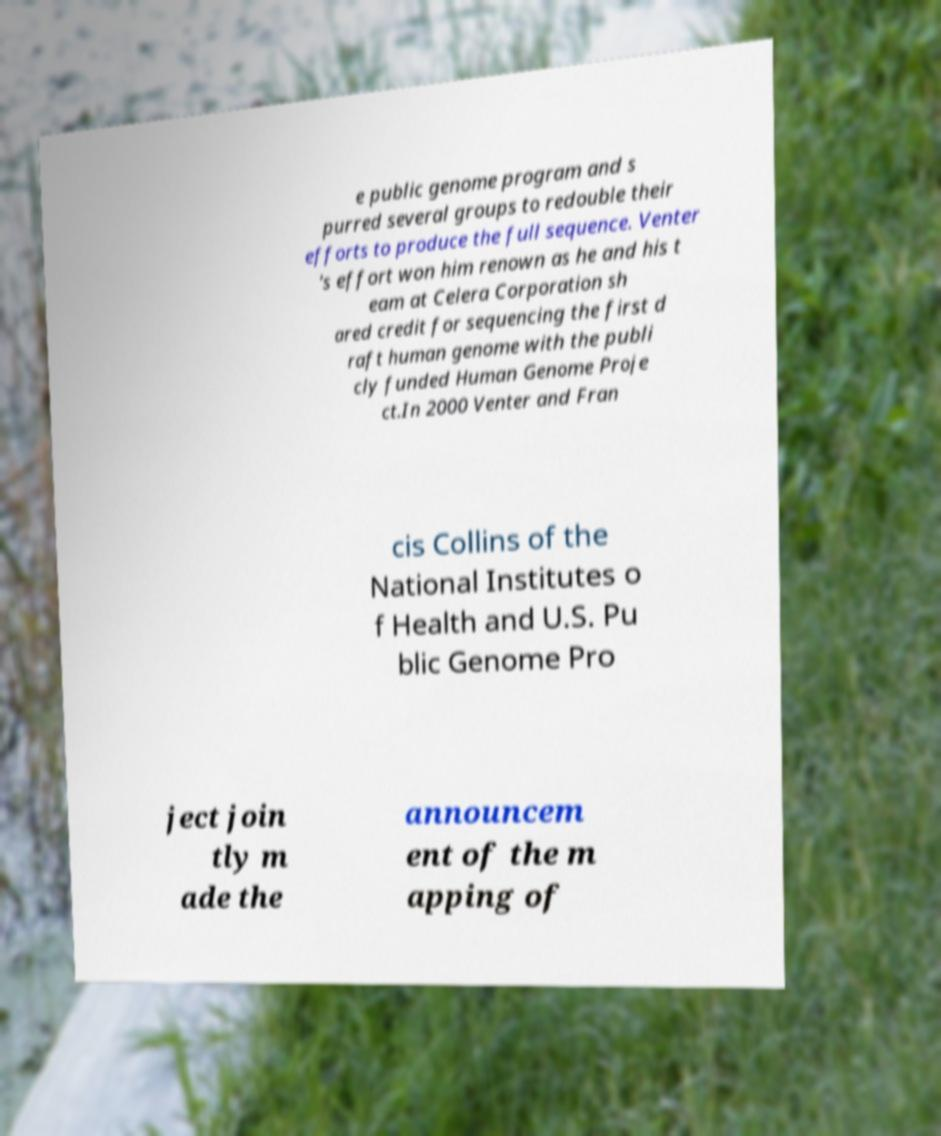Please read and relay the text visible in this image. What does it say? e public genome program and s purred several groups to redouble their efforts to produce the full sequence. Venter 's effort won him renown as he and his t eam at Celera Corporation sh ared credit for sequencing the first d raft human genome with the publi cly funded Human Genome Proje ct.In 2000 Venter and Fran cis Collins of the National Institutes o f Health and U.S. Pu blic Genome Pro ject join tly m ade the announcem ent of the m apping of 